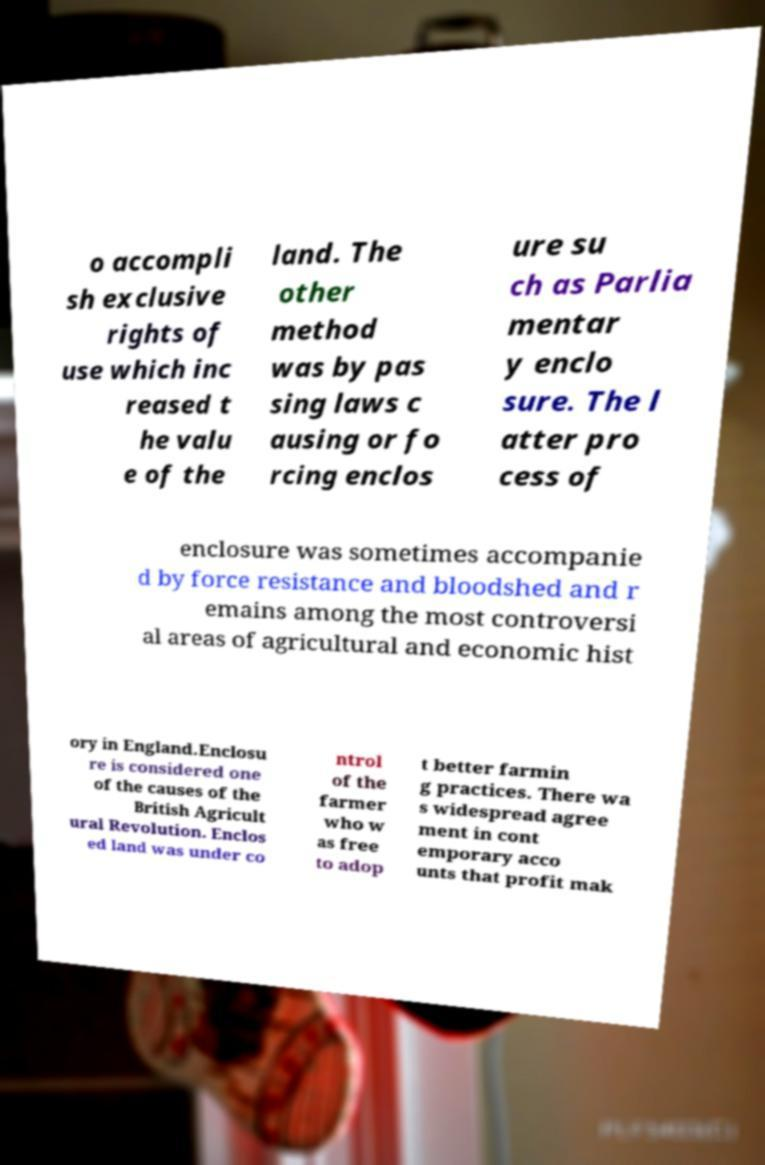For documentation purposes, I need the text within this image transcribed. Could you provide that? o accompli sh exclusive rights of use which inc reased t he valu e of the land. The other method was by pas sing laws c ausing or fo rcing enclos ure su ch as Parlia mentar y enclo sure. The l atter pro cess of enclosure was sometimes accompanie d by force resistance and bloodshed and r emains among the most controversi al areas of agricultural and economic hist ory in England.Enclosu re is considered one of the causes of the British Agricult ural Revolution. Enclos ed land was under co ntrol of the farmer who w as free to adop t better farmin g practices. There wa s widespread agree ment in cont emporary acco unts that profit mak 